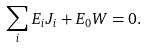<formula> <loc_0><loc_0><loc_500><loc_500>\sum _ { i } E _ { i } J _ { i } + E _ { 0 } W = 0 .</formula> 